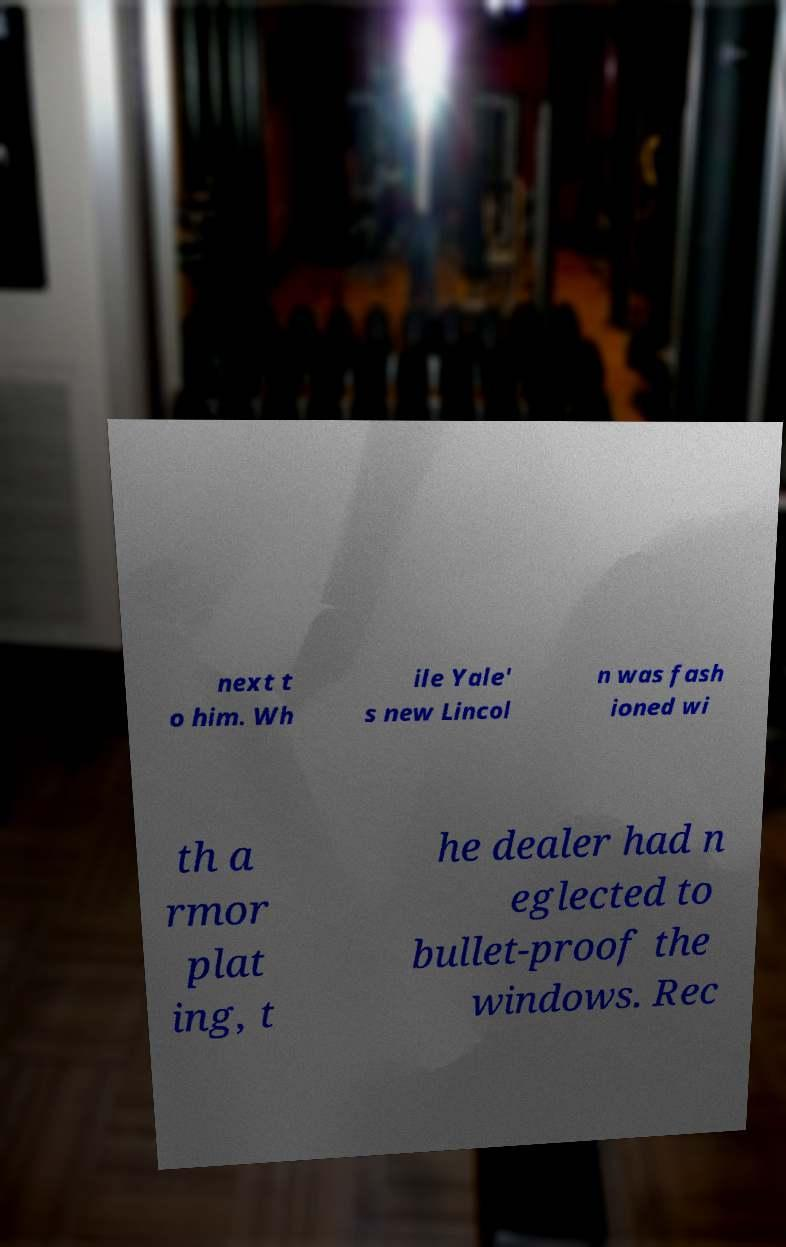Please identify and transcribe the text found in this image. next t o him. Wh ile Yale' s new Lincol n was fash ioned wi th a rmor plat ing, t he dealer had n eglected to bullet-proof the windows. Rec 